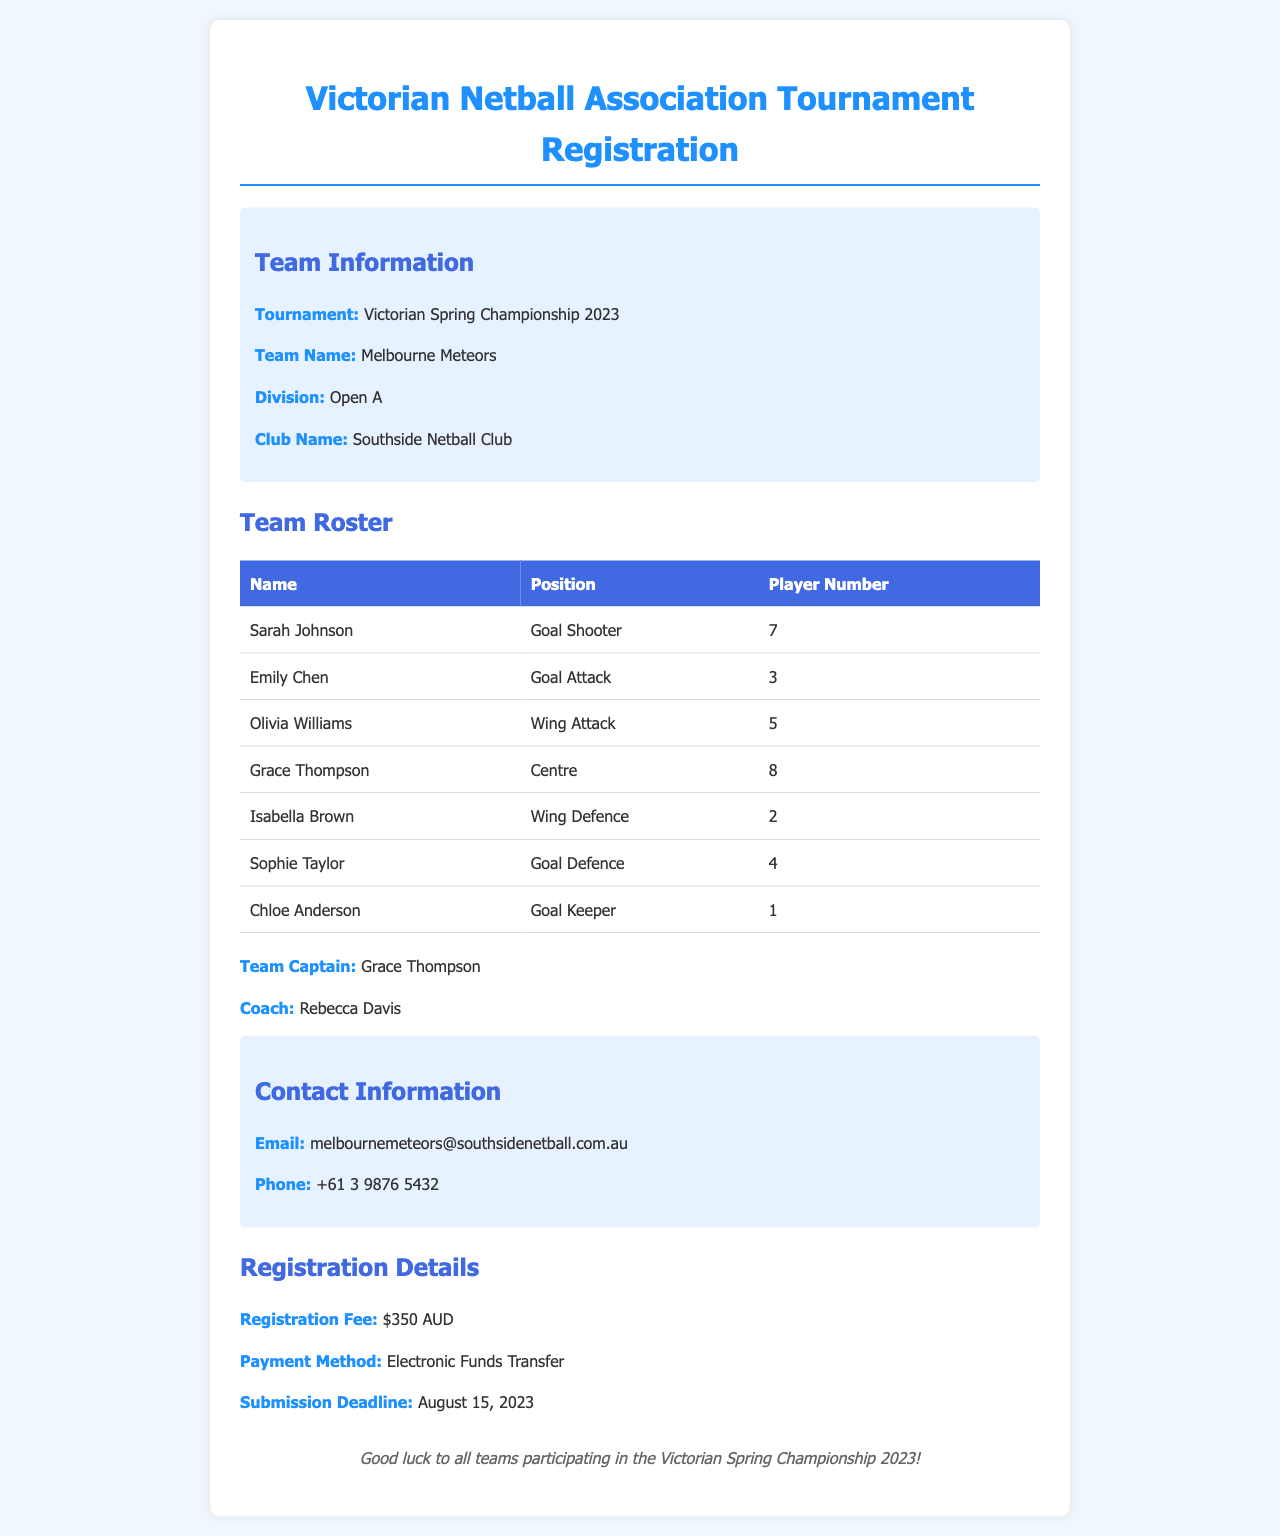What is the tournament name? The tournament name is given in the document under Team Information.
Answer: Victorian Spring Championship 2023 Who is the team captain? The name of the team captain is highlighted in the document.
Answer: Grace Thompson What is the division of the team? The division is specified in the Team Information section of the document.
Answer: Open A How many players are on the team roster? The number of players can be counted from the Team Roster table in the document.
Answer: 7 What is the registration fee? The registration fee is stated in the Registration Details section of the document.
Answer: $350 AUD What is the deadline for submission? The submission deadline is listed under Registration Details in the document.
Answer: August 15, 2023 What is the email address provided for contact? The email address is located in the Contact Information section of the document.
Answer: melbournemeteors@southsidenetball.com.au What player number does the Goal Keeper have? The player number for the Goal Keeper can be found in the Team Roster table.
Answer: 1 How is the registration fee supposed to be paid? The payment method is indicated in the Registration Details section of the document.
Answer: Electronic Funds Transfer 